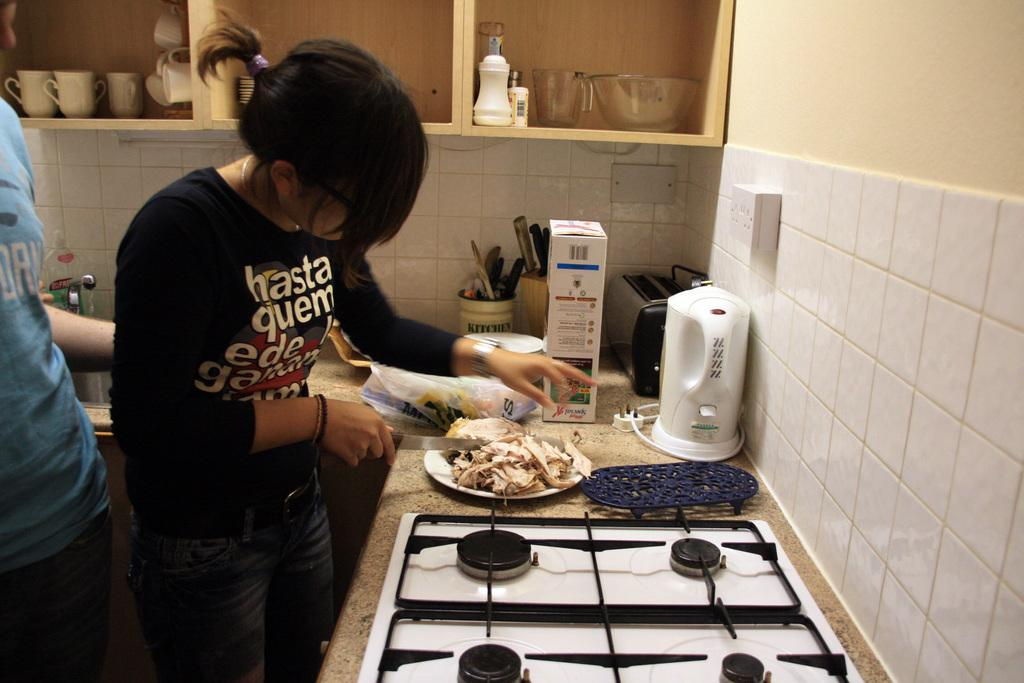<image>
Describe the image concisely. a lady with a black shirt that says hasta 